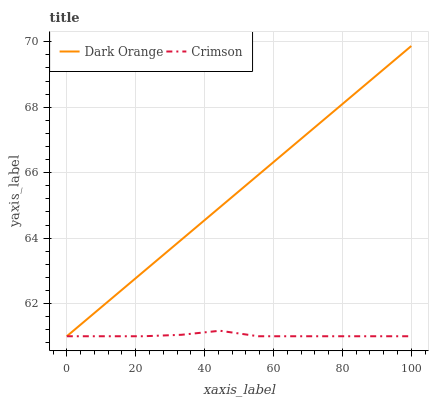Does Crimson have the minimum area under the curve?
Answer yes or no. Yes. Does Dark Orange have the maximum area under the curve?
Answer yes or no. Yes. Does Dark Orange have the minimum area under the curve?
Answer yes or no. No. Is Dark Orange the smoothest?
Answer yes or no. Yes. Is Crimson the roughest?
Answer yes or no. Yes. Is Dark Orange the roughest?
Answer yes or no. No. Does Crimson have the lowest value?
Answer yes or no. Yes. Does Dark Orange have the highest value?
Answer yes or no. Yes. Does Crimson intersect Dark Orange?
Answer yes or no. Yes. Is Crimson less than Dark Orange?
Answer yes or no. No. Is Crimson greater than Dark Orange?
Answer yes or no. No. 